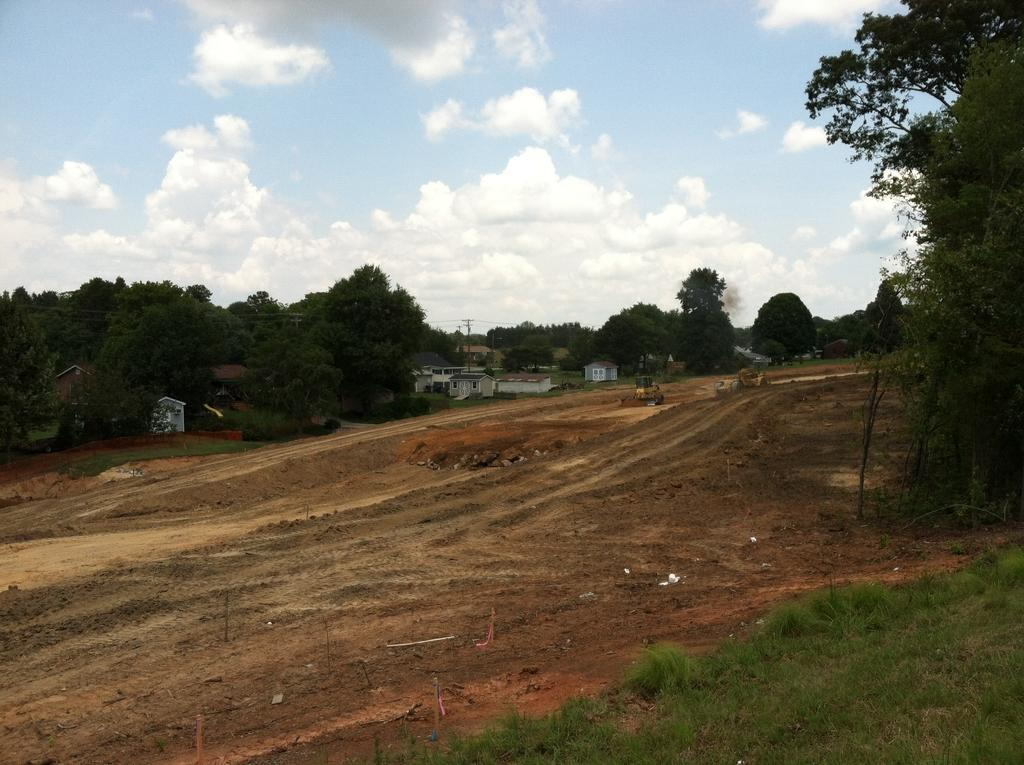What type of vegetation can be seen in the image? There are trees in the image. What type of structures are present in the image? There are houses in the image. What is at the bottom of the image? There is grass and soil at the bottom of the image. What is visible at the top of the image? There is sky visible at the top of the image. What can be seen in the sky? There are clouds in the sky. What type of cheese is being used to write on the grass in the image? There is no cheese present in the image, and therefore no such activity can be observed. What kind of pen is being used to draw on the houses in the image? There is no pen or drawing activity present in the image; the houses are simply structures. 